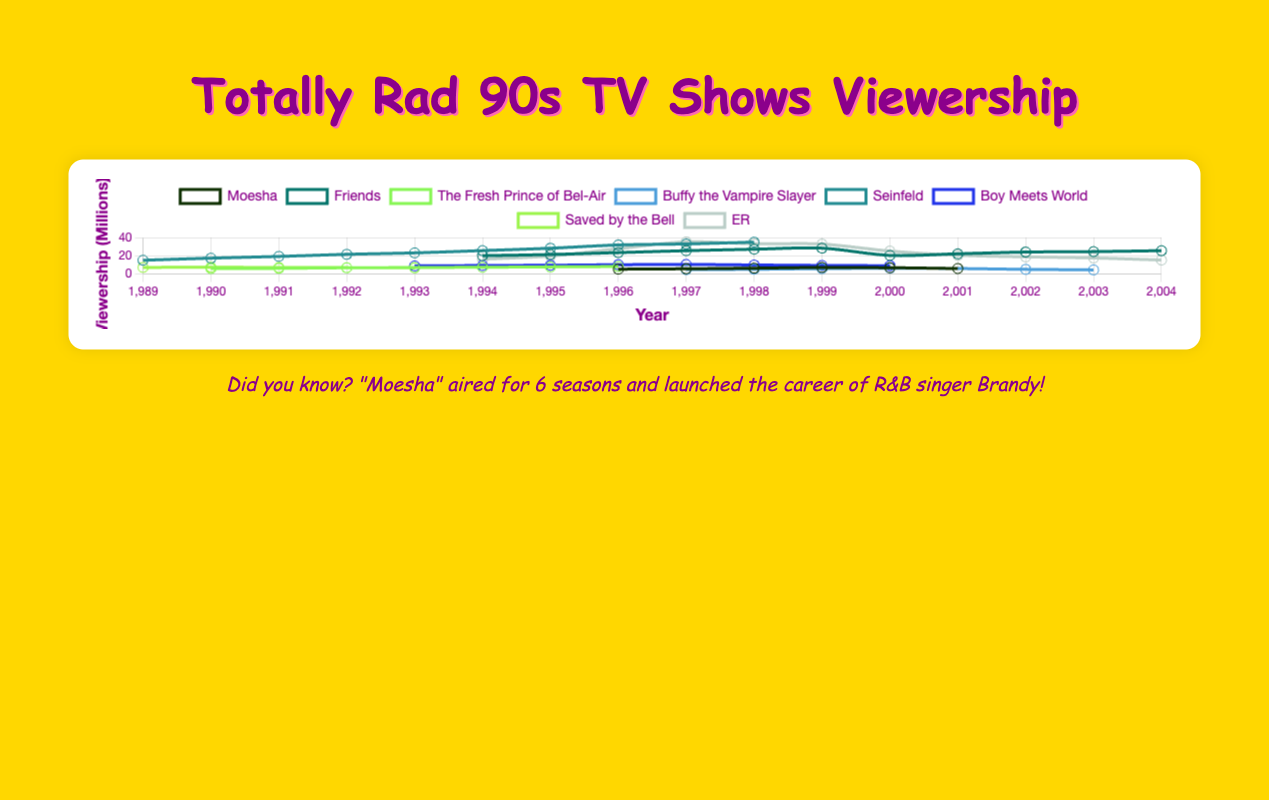Which show had the highest viewership on average? To find which show had the highest viewership on average, calculate the mean viewership for each show and compare them. For example, "Friends" has 11 data points, and the sum of its viewership is 262.5, so the average is 262.5 / 11 = 23.9 million. Repeat this for all shows and compare. "Seinfeld" averages at 24.14 million, which is the highest.
Answer: Seinfeld Which show had the largest drop in viewership from one year to the next? Look at the year-to-year changes in viewership for all shows. "ER" had a significant drop from 1999 to 2000, from 32.8 million viewers to 25.1 million (a difference of 7.7 million). This is the largest drop found.
Answer: ER How does the viewership pattern of "Moesha" compare with "The Fresh Prince of Bel-Air"? To compare patterns, look at the trend lines of both shows. "Moesha" started lower at 5.2 million in 1996 and peaked at 7.1 million in 1999 before declining. "The Fresh Prince of Bel-Air" consistently increased from 5.8 million in 1990 to 8.1 million in 1996. "The Fresh Prince of Bel-Air" had a steady increase, whereas "Moesha" had a peak followed by a decline.
Answer: "The Fresh Prince of Bel-Air" had a steady increase, while "Moesha" peaked and then declined What was the maximum viewership reached by "Friends"? Locate the highest data point in the "Friends" graph. The peak viewership is 28.3 million in 1999.
Answer: 28.3 million During what year did "Saved by the Bell" have the second-highest viewership? Rank the viewership values of "Saved by the Bell" to find the second-largest value and its corresponding year. The second-highest viewership is 7.3 million in 1990.
Answer: 1990 Which show maintained a constant or increasing viewership throughout its entire run? Analyze each show's trend line to identify any declines. "The Fresh Prince of Bel-Air" maintained an increasing viewership every year from 1990 to 1996 without any drops.
Answer: The Fresh Prince of Bel-Air Between "Buffy the Vampire Slayer" and "Boy Meets World," which show had a higher average viewership? Calculate the average viewership for both shows. "Buffy the Vampire Slayer" had an average of (4.7 + 5.1 + 5.8 + 6.3 + 5.9 + 5.0 + 4.4) / 7 ≈ 5.31 million, whereas "Boy Meets World" had an average of (8.8 + 9.2 + 9.5 + 10.1 + 10.4 + 9.8 + 9.3 + 9.0) / 8 = 9.39 million.
Answer: Boy Meets World 